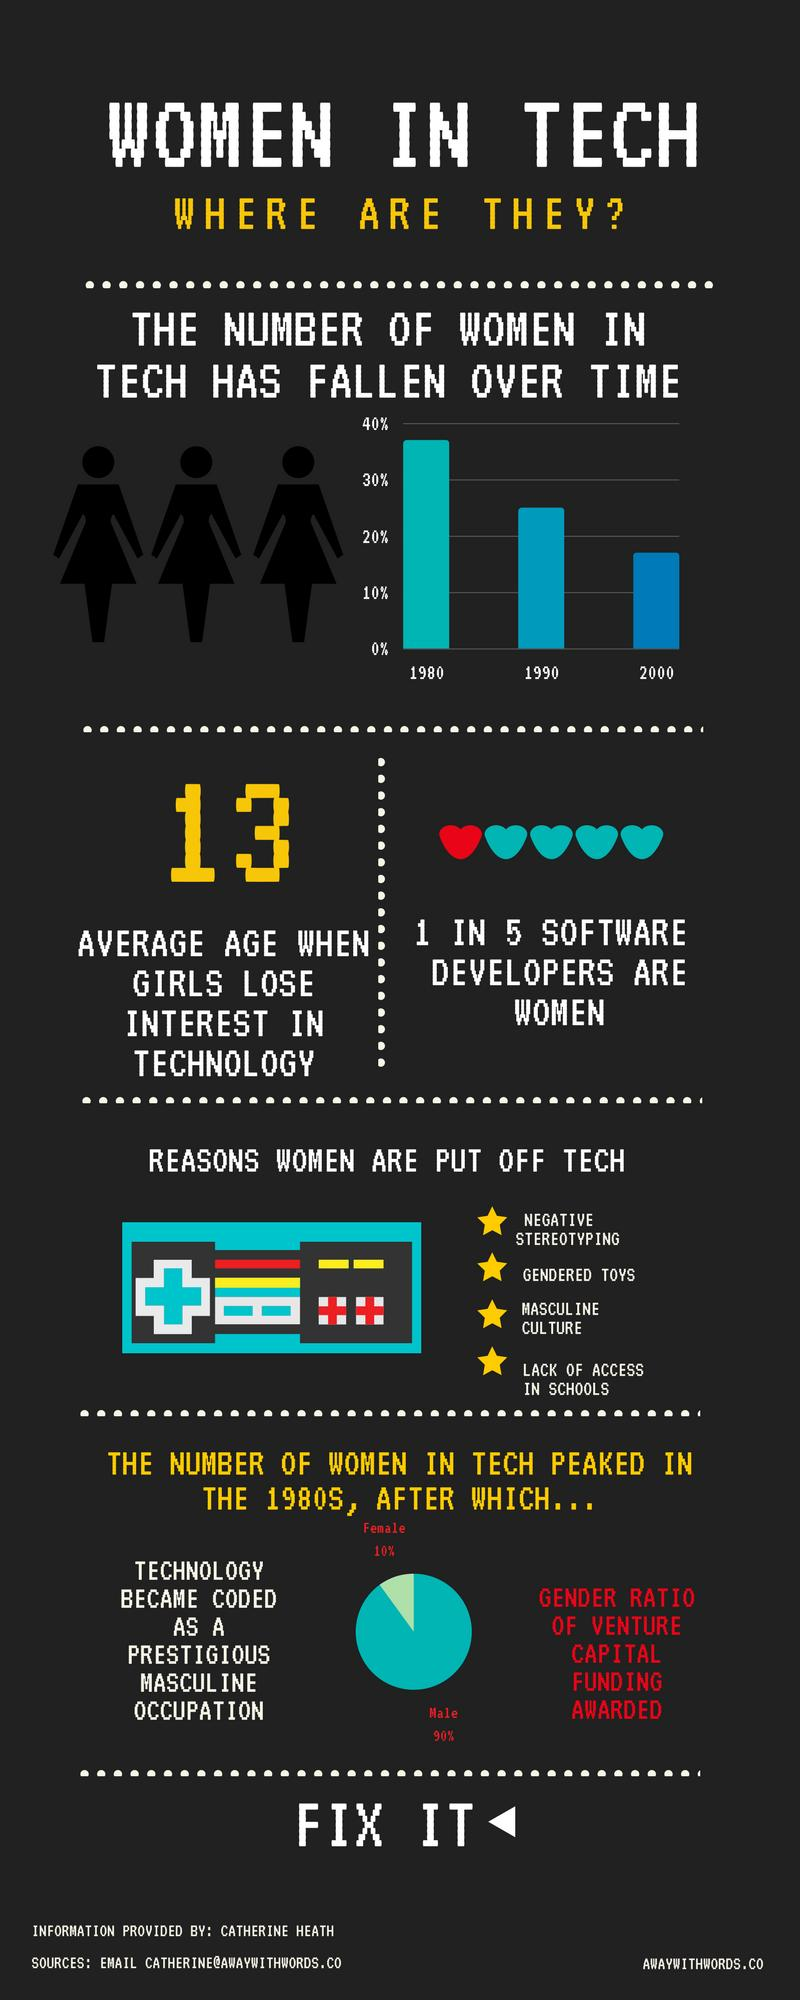Indicate a few pertinent items in this graphic. According to the data, only 10% of women were awarded venture capital funding. The average age when girls lose interest in technology is 13. 